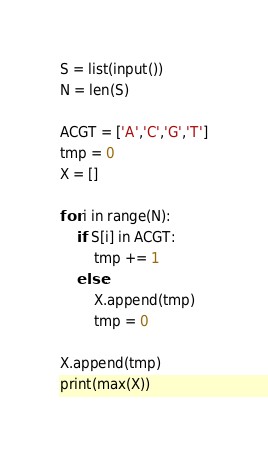<code> <loc_0><loc_0><loc_500><loc_500><_Python_>S = list(input())
N = len(S)

ACGT = ['A','C','G','T']
tmp = 0
X = []

for i in range(N):
    if S[i] in ACGT:
        tmp += 1
    else:
        X.append(tmp)
        tmp = 0

X.append(tmp)
print(max(X))
</code> 